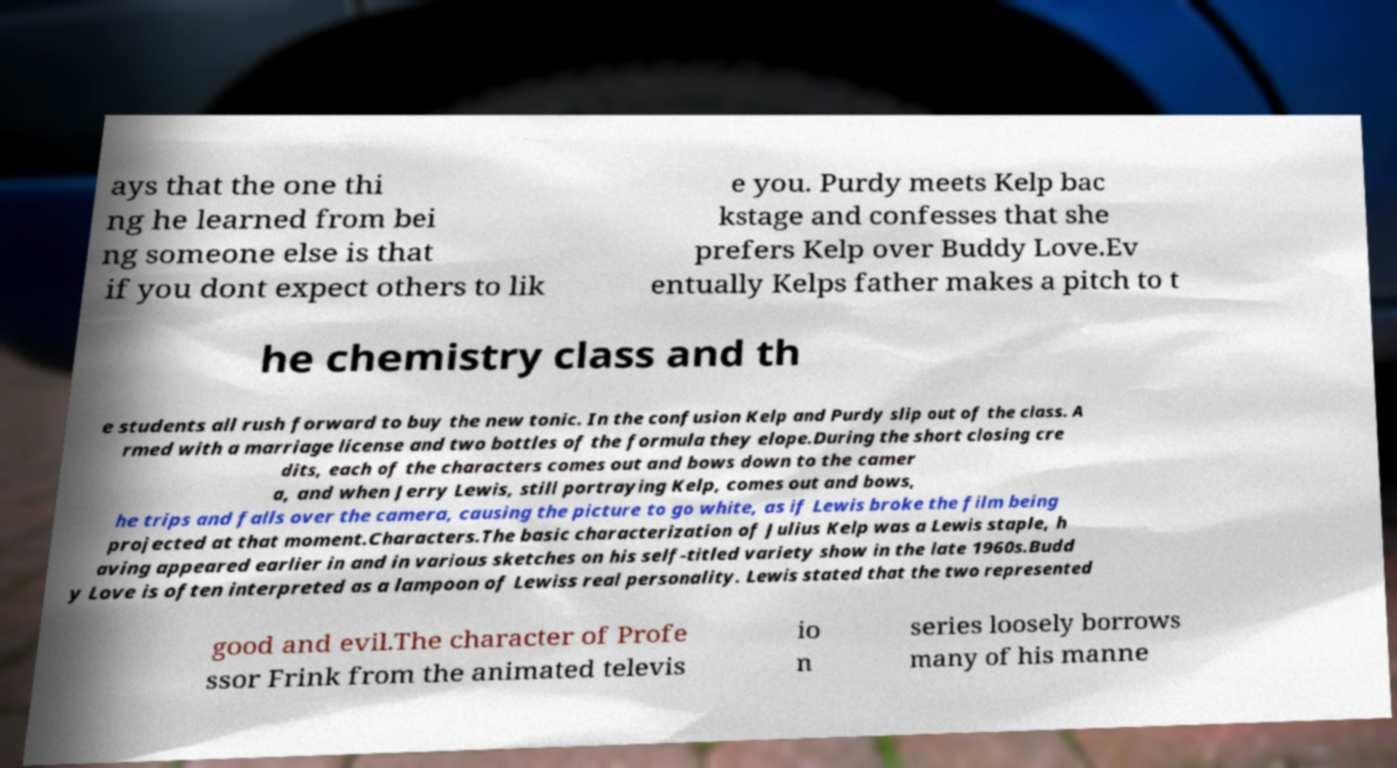For documentation purposes, I need the text within this image transcribed. Could you provide that? ays that the one thi ng he learned from bei ng someone else is that if you dont expect others to lik e you. Purdy meets Kelp bac kstage and confesses that she prefers Kelp over Buddy Love.Ev entually Kelps father makes a pitch to t he chemistry class and th e students all rush forward to buy the new tonic. In the confusion Kelp and Purdy slip out of the class. A rmed with a marriage license and two bottles of the formula they elope.During the short closing cre dits, each of the characters comes out and bows down to the camer a, and when Jerry Lewis, still portraying Kelp, comes out and bows, he trips and falls over the camera, causing the picture to go white, as if Lewis broke the film being projected at that moment.Characters.The basic characterization of Julius Kelp was a Lewis staple, h aving appeared earlier in and in various sketches on his self-titled variety show in the late 1960s.Budd y Love is often interpreted as a lampoon of Lewiss real personality. Lewis stated that the two represented good and evil.The character of Profe ssor Frink from the animated televis io n series loosely borrows many of his manne 